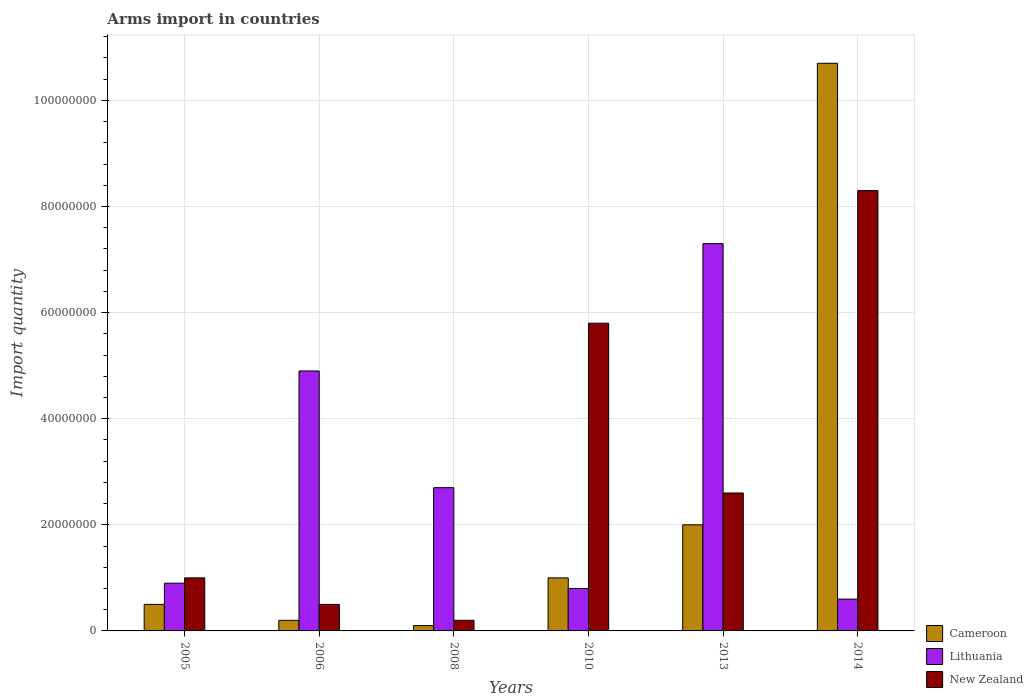How many different coloured bars are there?
Your answer should be very brief. 3. How many bars are there on the 3rd tick from the right?
Offer a very short reply. 3. In how many cases, is the number of bars for a given year not equal to the number of legend labels?
Your answer should be very brief. 0. What is the total arms import in Lithuania in 2013?
Provide a short and direct response. 7.30e+07. Across all years, what is the maximum total arms import in Lithuania?
Your answer should be compact. 7.30e+07. Across all years, what is the minimum total arms import in Cameroon?
Give a very brief answer. 1.00e+06. In which year was the total arms import in Cameroon minimum?
Keep it short and to the point. 2008. What is the total total arms import in Lithuania in the graph?
Keep it short and to the point. 1.72e+08. What is the difference between the total arms import in Lithuania in 2006 and that in 2014?
Ensure brevity in your answer.  4.30e+07. What is the difference between the total arms import in New Zealand in 2005 and the total arms import in Cameroon in 2013?
Provide a succinct answer. -1.00e+07. What is the average total arms import in Cameroon per year?
Keep it short and to the point. 2.42e+07. In the year 2006, what is the difference between the total arms import in New Zealand and total arms import in Cameroon?
Your answer should be compact. 3.00e+06. What is the ratio of the total arms import in Lithuania in 2006 to that in 2014?
Your answer should be compact. 8.17. What is the difference between the highest and the second highest total arms import in Cameroon?
Provide a succinct answer. 8.70e+07. What is the difference between the highest and the lowest total arms import in New Zealand?
Make the answer very short. 8.10e+07. Is the sum of the total arms import in New Zealand in 2005 and 2008 greater than the maximum total arms import in Lithuania across all years?
Your response must be concise. No. What does the 2nd bar from the left in 2008 represents?
Your response must be concise. Lithuania. What does the 3rd bar from the right in 2014 represents?
Give a very brief answer. Cameroon. Are all the bars in the graph horizontal?
Ensure brevity in your answer.  No. How many years are there in the graph?
Give a very brief answer. 6. Are the values on the major ticks of Y-axis written in scientific E-notation?
Keep it short and to the point. No. Does the graph contain any zero values?
Give a very brief answer. No. How many legend labels are there?
Provide a succinct answer. 3. What is the title of the graph?
Offer a terse response. Arms import in countries. Does "Senegal" appear as one of the legend labels in the graph?
Your response must be concise. No. What is the label or title of the X-axis?
Make the answer very short. Years. What is the label or title of the Y-axis?
Provide a short and direct response. Import quantity. What is the Import quantity of Cameroon in 2005?
Offer a very short reply. 5.00e+06. What is the Import quantity of Lithuania in 2005?
Your response must be concise. 9.00e+06. What is the Import quantity of Cameroon in 2006?
Make the answer very short. 2.00e+06. What is the Import quantity in Lithuania in 2006?
Make the answer very short. 4.90e+07. What is the Import quantity of Lithuania in 2008?
Your answer should be very brief. 2.70e+07. What is the Import quantity of New Zealand in 2008?
Keep it short and to the point. 2.00e+06. What is the Import quantity in New Zealand in 2010?
Make the answer very short. 5.80e+07. What is the Import quantity of Cameroon in 2013?
Your response must be concise. 2.00e+07. What is the Import quantity of Lithuania in 2013?
Your answer should be very brief. 7.30e+07. What is the Import quantity of New Zealand in 2013?
Make the answer very short. 2.60e+07. What is the Import quantity of Cameroon in 2014?
Make the answer very short. 1.07e+08. What is the Import quantity in Lithuania in 2014?
Keep it short and to the point. 6.00e+06. What is the Import quantity of New Zealand in 2014?
Give a very brief answer. 8.30e+07. Across all years, what is the maximum Import quantity in Cameroon?
Provide a succinct answer. 1.07e+08. Across all years, what is the maximum Import quantity in Lithuania?
Keep it short and to the point. 7.30e+07. Across all years, what is the maximum Import quantity of New Zealand?
Keep it short and to the point. 8.30e+07. Across all years, what is the minimum Import quantity in Lithuania?
Offer a very short reply. 6.00e+06. Across all years, what is the minimum Import quantity in New Zealand?
Your answer should be compact. 2.00e+06. What is the total Import quantity in Cameroon in the graph?
Give a very brief answer. 1.45e+08. What is the total Import quantity in Lithuania in the graph?
Your answer should be compact. 1.72e+08. What is the total Import quantity in New Zealand in the graph?
Provide a succinct answer. 1.84e+08. What is the difference between the Import quantity of Lithuania in 2005 and that in 2006?
Your answer should be compact. -4.00e+07. What is the difference between the Import quantity of New Zealand in 2005 and that in 2006?
Your answer should be compact. 5.00e+06. What is the difference between the Import quantity in Cameroon in 2005 and that in 2008?
Your answer should be compact. 4.00e+06. What is the difference between the Import quantity of Lithuania in 2005 and that in 2008?
Offer a terse response. -1.80e+07. What is the difference between the Import quantity of Cameroon in 2005 and that in 2010?
Make the answer very short. -5.00e+06. What is the difference between the Import quantity in Lithuania in 2005 and that in 2010?
Give a very brief answer. 1.00e+06. What is the difference between the Import quantity in New Zealand in 2005 and that in 2010?
Make the answer very short. -4.80e+07. What is the difference between the Import quantity of Cameroon in 2005 and that in 2013?
Provide a succinct answer. -1.50e+07. What is the difference between the Import quantity in Lithuania in 2005 and that in 2013?
Your answer should be compact. -6.40e+07. What is the difference between the Import quantity in New Zealand in 2005 and that in 2013?
Offer a very short reply. -1.60e+07. What is the difference between the Import quantity of Cameroon in 2005 and that in 2014?
Keep it short and to the point. -1.02e+08. What is the difference between the Import quantity in New Zealand in 2005 and that in 2014?
Offer a very short reply. -7.30e+07. What is the difference between the Import quantity of Lithuania in 2006 and that in 2008?
Your answer should be very brief. 2.20e+07. What is the difference between the Import quantity of New Zealand in 2006 and that in 2008?
Provide a short and direct response. 3.00e+06. What is the difference between the Import quantity in Cameroon in 2006 and that in 2010?
Provide a short and direct response. -8.00e+06. What is the difference between the Import quantity in Lithuania in 2006 and that in 2010?
Your answer should be very brief. 4.10e+07. What is the difference between the Import quantity of New Zealand in 2006 and that in 2010?
Keep it short and to the point. -5.30e+07. What is the difference between the Import quantity in Cameroon in 2006 and that in 2013?
Give a very brief answer. -1.80e+07. What is the difference between the Import quantity in Lithuania in 2006 and that in 2013?
Provide a succinct answer. -2.40e+07. What is the difference between the Import quantity of New Zealand in 2006 and that in 2013?
Provide a succinct answer. -2.10e+07. What is the difference between the Import quantity in Cameroon in 2006 and that in 2014?
Offer a terse response. -1.05e+08. What is the difference between the Import quantity of Lithuania in 2006 and that in 2014?
Keep it short and to the point. 4.30e+07. What is the difference between the Import quantity of New Zealand in 2006 and that in 2014?
Ensure brevity in your answer.  -7.80e+07. What is the difference between the Import quantity in Cameroon in 2008 and that in 2010?
Keep it short and to the point. -9.00e+06. What is the difference between the Import quantity in Lithuania in 2008 and that in 2010?
Your response must be concise. 1.90e+07. What is the difference between the Import quantity of New Zealand in 2008 and that in 2010?
Ensure brevity in your answer.  -5.60e+07. What is the difference between the Import quantity of Cameroon in 2008 and that in 2013?
Your answer should be very brief. -1.90e+07. What is the difference between the Import quantity of Lithuania in 2008 and that in 2013?
Ensure brevity in your answer.  -4.60e+07. What is the difference between the Import quantity in New Zealand in 2008 and that in 2013?
Your response must be concise. -2.40e+07. What is the difference between the Import quantity of Cameroon in 2008 and that in 2014?
Offer a terse response. -1.06e+08. What is the difference between the Import quantity in Lithuania in 2008 and that in 2014?
Provide a short and direct response. 2.10e+07. What is the difference between the Import quantity of New Zealand in 2008 and that in 2014?
Provide a short and direct response. -8.10e+07. What is the difference between the Import quantity in Cameroon in 2010 and that in 2013?
Keep it short and to the point. -1.00e+07. What is the difference between the Import quantity in Lithuania in 2010 and that in 2013?
Offer a very short reply. -6.50e+07. What is the difference between the Import quantity of New Zealand in 2010 and that in 2013?
Keep it short and to the point. 3.20e+07. What is the difference between the Import quantity of Cameroon in 2010 and that in 2014?
Your response must be concise. -9.70e+07. What is the difference between the Import quantity in Lithuania in 2010 and that in 2014?
Make the answer very short. 2.00e+06. What is the difference between the Import quantity of New Zealand in 2010 and that in 2014?
Your answer should be compact. -2.50e+07. What is the difference between the Import quantity in Cameroon in 2013 and that in 2014?
Provide a succinct answer. -8.70e+07. What is the difference between the Import quantity of Lithuania in 2013 and that in 2014?
Your response must be concise. 6.70e+07. What is the difference between the Import quantity in New Zealand in 2013 and that in 2014?
Provide a short and direct response. -5.70e+07. What is the difference between the Import quantity in Cameroon in 2005 and the Import quantity in Lithuania in 2006?
Offer a very short reply. -4.40e+07. What is the difference between the Import quantity in Cameroon in 2005 and the Import quantity in New Zealand in 2006?
Your answer should be very brief. 0. What is the difference between the Import quantity of Lithuania in 2005 and the Import quantity of New Zealand in 2006?
Your answer should be very brief. 4.00e+06. What is the difference between the Import quantity of Cameroon in 2005 and the Import quantity of Lithuania in 2008?
Keep it short and to the point. -2.20e+07. What is the difference between the Import quantity of Cameroon in 2005 and the Import quantity of New Zealand in 2008?
Offer a very short reply. 3.00e+06. What is the difference between the Import quantity of Lithuania in 2005 and the Import quantity of New Zealand in 2008?
Keep it short and to the point. 7.00e+06. What is the difference between the Import quantity in Cameroon in 2005 and the Import quantity in Lithuania in 2010?
Provide a succinct answer. -3.00e+06. What is the difference between the Import quantity of Cameroon in 2005 and the Import quantity of New Zealand in 2010?
Make the answer very short. -5.30e+07. What is the difference between the Import quantity of Lithuania in 2005 and the Import quantity of New Zealand in 2010?
Your answer should be very brief. -4.90e+07. What is the difference between the Import quantity in Cameroon in 2005 and the Import quantity in Lithuania in 2013?
Provide a succinct answer. -6.80e+07. What is the difference between the Import quantity in Cameroon in 2005 and the Import quantity in New Zealand in 2013?
Keep it short and to the point. -2.10e+07. What is the difference between the Import quantity of Lithuania in 2005 and the Import quantity of New Zealand in 2013?
Your answer should be compact. -1.70e+07. What is the difference between the Import quantity of Cameroon in 2005 and the Import quantity of Lithuania in 2014?
Ensure brevity in your answer.  -1.00e+06. What is the difference between the Import quantity in Cameroon in 2005 and the Import quantity in New Zealand in 2014?
Your answer should be very brief. -7.80e+07. What is the difference between the Import quantity in Lithuania in 2005 and the Import quantity in New Zealand in 2014?
Keep it short and to the point. -7.40e+07. What is the difference between the Import quantity of Cameroon in 2006 and the Import quantity of Lithuania in 2008?
Keep it short and to the point. -2.50e+07. What is the difference between the Import quantity of Lithuania in 2006 and the Import quantity of New Zealand in 2008?
Make the answer very short. 4.70e+07. What is the difference between the Import quantity in Cameroon in 2006 and the Import quantity in Lithuania in 2010?
Provide a short and direct response. -6.00e+06. What is the difference between the Import quantity in Cameroon in 2006 and the Import quantity in New Zealand in 2010?
Your response must be concise. -5.60e+07. What is the difference between the Import quantity of Lithuania in 2006 and the Import quantity of New Zealand in 2010?
Provide a short and direct response. -9.00e+06. What is the difference between the Import quantity of Cameroon in 2006 and the Import quantity of Lithuania in 2013?
Your answer should be compact. -7.10e+07. What is the difference between the Import quantity in Cameroon in 2006 and the Import quantity in New Zealand in 2013?
Your answer should be compact. -2.40e+07. What is the difference between the Import quantity in Lithuania in 2006 and the Import quantity in New Zealand in 2013?
Your response must be concise. 2.30e+07. What is the difference between the Import quantity of Cameroon in 2006 and the Import quantity of Lithuania in 2014?
Your answer should be very brief. -4.00e+06. What is the difference between the Import quantity of Cameroon in 2006 and the Import quantity of New Zealand in 2014?
Keep it short and to the point. -8.10e+07. What is the difference between the Import quantity in Lithuania in 2006 and the Import quantity in New Zealand in 2014?
Provide a succinct answer. -3.40e+07. What is the difference between the Import quantity in Cameroon in 2008 and the Import quantity in Lithuania in 2010?
Give a very brief answer. -7.00e+06. What is the difference between the Import quantity of Cameroon in 2008 and the Import quantity of New Zealand in 2010?
Your answer should be compact. -5.70e+07. What is the difference between the Import quantity of Lithuania in 2008 and the Import quantity of New Zealand in 2010?
Your answer should be compact. -3.10e+07. What is the difference between the Import quantity of Cameroon in 2008 and the Import quantity of Lithuania in 2013?
Make the answer very short. -7.20e+07. What is the difference between the Import quantity in Cameroon in 2008 and the Import quantity in New Zealand in 2013?
Your response must be concise. -2.50e+07. What is the difference between the Import quantity in Lithuania in 2008 and the Import quantity in New Zealand in 2013?
Ensure brevity in your answer.  1.00e+06. What is the difference between the Import quantity of Cameroon in 2008 and the Import quantity of Lithuania in 2014?
Your answer should be compact. -5.00e+06. What is the difference between the Import quantity in Cameroon in 2008 and the Import quantity in New Zealand in 2014?
Your answer should be very brief. -8.20e+07. What is the difference between the Import quantity in Lithuania in 2008 and the Import quantity in New Zealand in 2014?
Keep it short and to the point. -5.60e+07. What is the difference between the Import quantity in Cameroon in 2010 and the Import quantity in Lithuania in 2013?
Your response must be concise. -6.30e+07. What is the difference between the Import quantity of Cameroon in 2010 and the Import quantity of New Zealand in 2013?
Your answer should be compact. -1.60e+07. What is the difference between the Import quantity in Lithuania in 2010 and the Import quantity in New Zealand in 2013?
Make the answer very short. -1.80e+07. What is the difference between the Import quantity of Cameroon in 2010 and the Import quantity of New Zealand in 2014?
Your answer should be very brief. -7.30e+07. What is the difference between the Import quantity of Lithuania in 2010 and the Import quantity of New Zealand in 2014?
Provide a short and direct response. -7.50e+07. What is the difference between the Import quantity of Cameroon in 2013 and the Import quantity of Lithuania in 2014?
Ensure brevity in your answer.  1.40e+07. What is the difference between the Import quantity in Cameroon in 2013 and the Import quantity in New Zealand in 2014?
Provide a succinct answer. -6.30e+07. What is the difference between the Import quantity of Lithuania in 2013 and the Import quantity of New Zealand in 2014?
Offer a terse response. -1.00e+07. What is the average Import quantity in Cameroon per year?
Give a very brief answer. 2.42e+07. What is the average Import quantity in Lithuania per year?
Keep it short and to the point. 2.87e+07. What is the average Import quantity of New Zealand per year?
Provide a short and direct response. 3.07e+07. In the year 2005, what is the difference between the Import quantity in Cameroon and Import quantity in Lithuania?
Offer a terse response. -4.00e+06. In the year 2005, what is the difference between the Import quantity of Cameroon and Import quantity of New Zealand?
Ensure brevity in your answer.  -5.00e+06. In the year 2006, what is the difference between the Import quantity of Cameroon and Import quantity of Lithuania?
Offer a terse response. -4.70e+07. In the year 2006, what is the difference between the Import quantity of Lithuania and Import quantity of New Zealand?
Offer a terse response. 4.40e+07. In the year 2008, what is the difference between the Import quantity of Cameroon and Import quantity of Lithuania?
Keep it short and to the point. -2.60e+07. In the year 2008, what is the difference between the Import quantity of Cameroon and Import quantity of New Zealand?
Make the answer very short. -1.00e+06. In the year 2008, what is the difference between the Import quantity in Lithuania and Import quantity in New Zealand?
Your answer should be very brief. 2.50e+07. In the year 2010, what is the difference between the Import quantity in Cameroon and Import quantity in New Zealand?
Your answer should be very brief. -4.80e+07. In the year 2010, what is the difference between the Import quantity in Lithuania and Import quantity in New Zealand?
Provide a succinct answer. -5.00e+07. In the year 2013, what is the difference between the Import quantity of Cameroon and Import quantity of Lithuania?
Your response must be concise. -5.30e+07. In the year 2013, what is the difference between the Import quantity in Cameroon and Import quantity in New Zealand?
Provide a short and direct response. -6.00e+06. In the year 2013, what is the difference between the Import quantity of Lithuania and Import quantity of New Zealand?
Keep it short and to the point. 4.70e+07. In the year 2014, what is the difference between the Import quantity in Cameroon and Import quantity in Lithuania?
Ensure brevity in your answer.  1.01e+08. In the year 2014, what is the difference between the Import quantity in Cameroon and Import quantity in New Zealand?
Ensure brevity in your answer.  2.40e+07. In the year 2014, what is the difference between the Import quantity of Lithuania and Import quantity of New Zealand?
Make the answer very short. -7.70e+07. What is the ratio of the Import quantity of Cameroon in 2005 to that in 2006?
Ensure brevity in your answer.  2.5. What is the ratio of the Import quantity in Lithuania in 2005 to that in 2006?
Offer a very short reply. 0.18. What is the ratio of the Import quantity in New Zealand in 2005 to that in 2006?
Your answer should be compact. 2. What is the ratio of the Import quantity of Cameroon in 2005 to that in 2008?
Make the answer very short. 5. What is the ratio of the Import quantity in Lithuania in 2005 to that in 2008?
Offer a terse response. 0.33. What is the ratio of the Import quantity in Cameroon in 2005 to that in 2010?
Offer a very short reply. 0.5. What is the ratio of the Import quantity of Lithuania in 2005 to that in 2010?
Your answer should be compact. 1.12. What is the ratio of the Import quantity of New Zealand in 2005 to that in 2010?
Give a very brief answer. 0.17. What is the ratio of the Import quantity in Lithuania in 2005 to that in 2013?
Ensure brevity in your answer.  0.12. What is the ratio of the Import quantity of New Zealand in 2005 to that in 2013?
Provide a short and direct response. 0.38. What is the ratio of the Import quantity of Cameroon in 2005 to that in 2014?
Your answer should be very brief. 0.05. What is the ratio of the Import quantity in New Zealand in 2005 to that in 2014?
Make the answer very short. 0.12. What is the ratio of the Import quantity of Cameroon in 2006 to that in 2008?
Offer a terse response. 2. What is the ratio of the Import quantity in Lithuania in 2006 to that in 2008?
Ensure brevity in your answer.  1.81. What is the ratio of the Import quantity in New Zealand in 2006 to that in 2008?
Keep it short and to the point. 2.5. What is the ratio of the Import quantity of Cameroon in 2006 to that in 2010?
Make the answer very short. 0.2. What is the ratio of the Import quantity of Lithuania in 2006 to that in 2010?
Provide a succinct answer. 6.12. What is the ratio of the Import quantity in New Zealand in 2006 to that in 2010?
Keep it short and to the point. 0.09. What is the ratio of the Import quantity in Cameroon in 2006 to that in 2013?
Keep it short and to the point. 0.1. What is the ratio of the Import quantity of Lithuania in 2006 to that in 2013?
Your response must be concise. 0.67. What is the ratio of the Import quantity in New Zealand in 2006 to that in 2013?
Offer a very short reply. 0.19. What is the ratio of the Import quantity in Cameroon in 2006 to that in 2014?
Your answer should be very brief. 0.02. What is the ratio of the Import quantity in Lithuania in 2006 to that in 2014?
Offer a terse response. 8.17. What is the ratio of the Import quantity in New Zealand in 2006 to that in 2014?
Provide a succinct answer. 0.06. What is the ratio of the Import quantity of Lithuania in 2008 to that in 2010?
Make the answer very short. 3.38. What is the ratio of the Import quantity in New Zealand in 2008 to that in 2010?
Keep it short and to the point. 0.03. What is the ratio of the Import quantity of Lithuania in 2008 to that in 2013?
Your answer should be compact. 0.37. What is the ratio of the Import quantity of New Zealand in 2008 to that in 2013?
Keep it short and to the point. 0.08. What is the ratio of the Import quantity in Cameroon in 2008 to that in 2014?
Provide a succinct answer. 0.01. What is the ratio of the Import quantity of New Zealand in 2008 to that in 2014?
Your response must be concise. 0.02. What is the ratio of the Import quantity in Cameroon in 2010 to that in 2013?
Offer a very short reply. 0.5. What is the ratio of the Import quantity of Lithuania in 2010 to that in 2013?
Offer a terse response. 0.11. What is the ratio of the Import quantity in New Zealand in 2010 to that in 2013?
Keep it short and to the point. 2.23. What is the ratio of the Import quantity of Cameroon in 2010 to that in 2014?
Offer a very short reply. 0.09. What is the ratio of the Import quantity of New Zealand in 2010 to that in 2014?
Give a very brief answer. 0.7. What is the ratio of the Import quantity in Cameroon in 2013 to that in 2014?
Your answer should be very brief. 0.19. What is the ratio of the Import quantity of Lithuania in 2013 to that in 2014?
Offer a very short reply. 12.17. What is the ratio of the Import quantity in New Zealand in 2013 to that in 2014?
Your response must be concise. 0.31. What is the difference between the highest and the second highest Import quantity in Cameroon?
Make the answer very short. 8.70e+07. What is the difference between the highest and the second highest Import quantity in Lithuania?
Your response must be concise. 2.40e+07. What is the difference between the highest and the second highest Import quantity in New Zealand?
Offer a terse response. 2.50e+07. What is the difference between the highest and the lowest Import quantity of Cameroon?
Give a very brief answer. 1.06e+08. What is the difference between the highest and the lowest Import quantity of Lithuania?
Make the answer very short. 6.70e+07. What is the difference between the highest and the lowest Import quantity in New Zealand?
Give a very brief answer. 8.10e+07. 